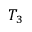<formula> <loc_0><loc_0><loc_500><loc_500>T _ { 3 }</formula> 